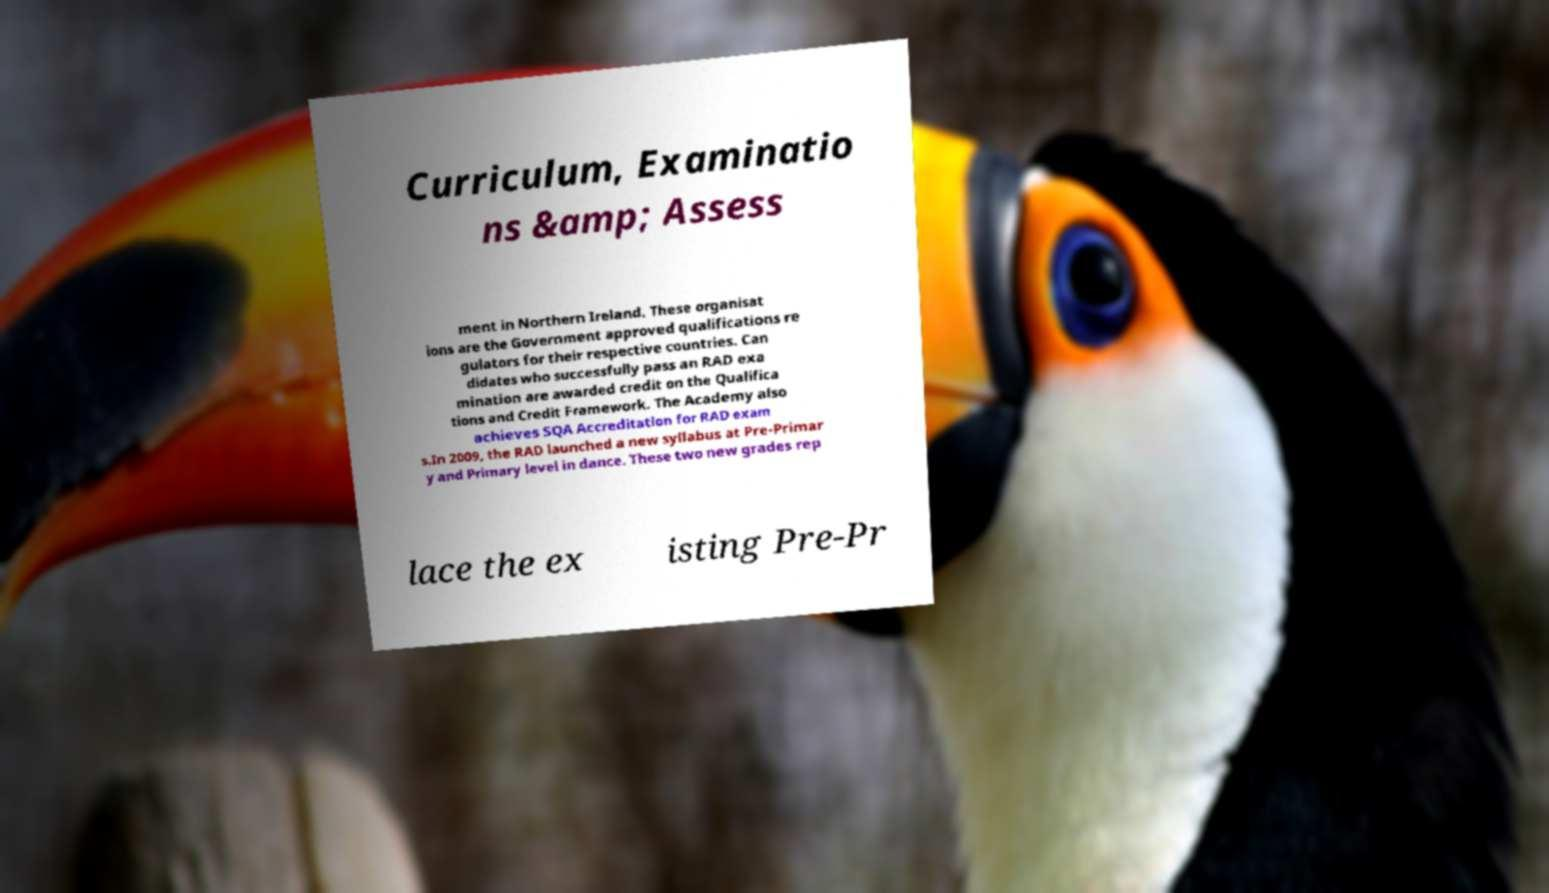I need the written content from this picture converted into text. Can you do that? Curriculum, Examinatio ns &amp; Assess ment in Northern Ireland. These organisat ions are the Government approved qualifications re gulators for their respective countries. Can didates who successfully pass an RAD exa mination are awarded credit on the Qualifica tions and Credit Framework. The Academy also achieves SQA Accreditation for RAD exam s.In 2009, the RAD launched a new syllabus at Pre-Primar y and Primary level in dance. These two new grades rep lace the ex isting Pre-Pr 